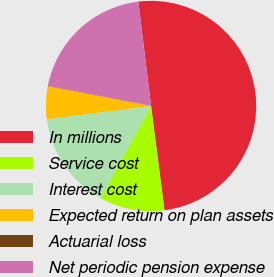<chart> <loc_0><loc_0><loc_500><loc_500><pie_chart><fcel>In millions<fcel>Service cost<fcel>Interest cost<fcel>Expected return on plan assets<fcel>Actuarial loss<fcel>Net periodic pension expense<nl><fcel>49.9%<fcel>10.02%<fcel>15.0%<fcel>5.03%<fcel>0.05%<fcel>19.99%<nl></chart> 